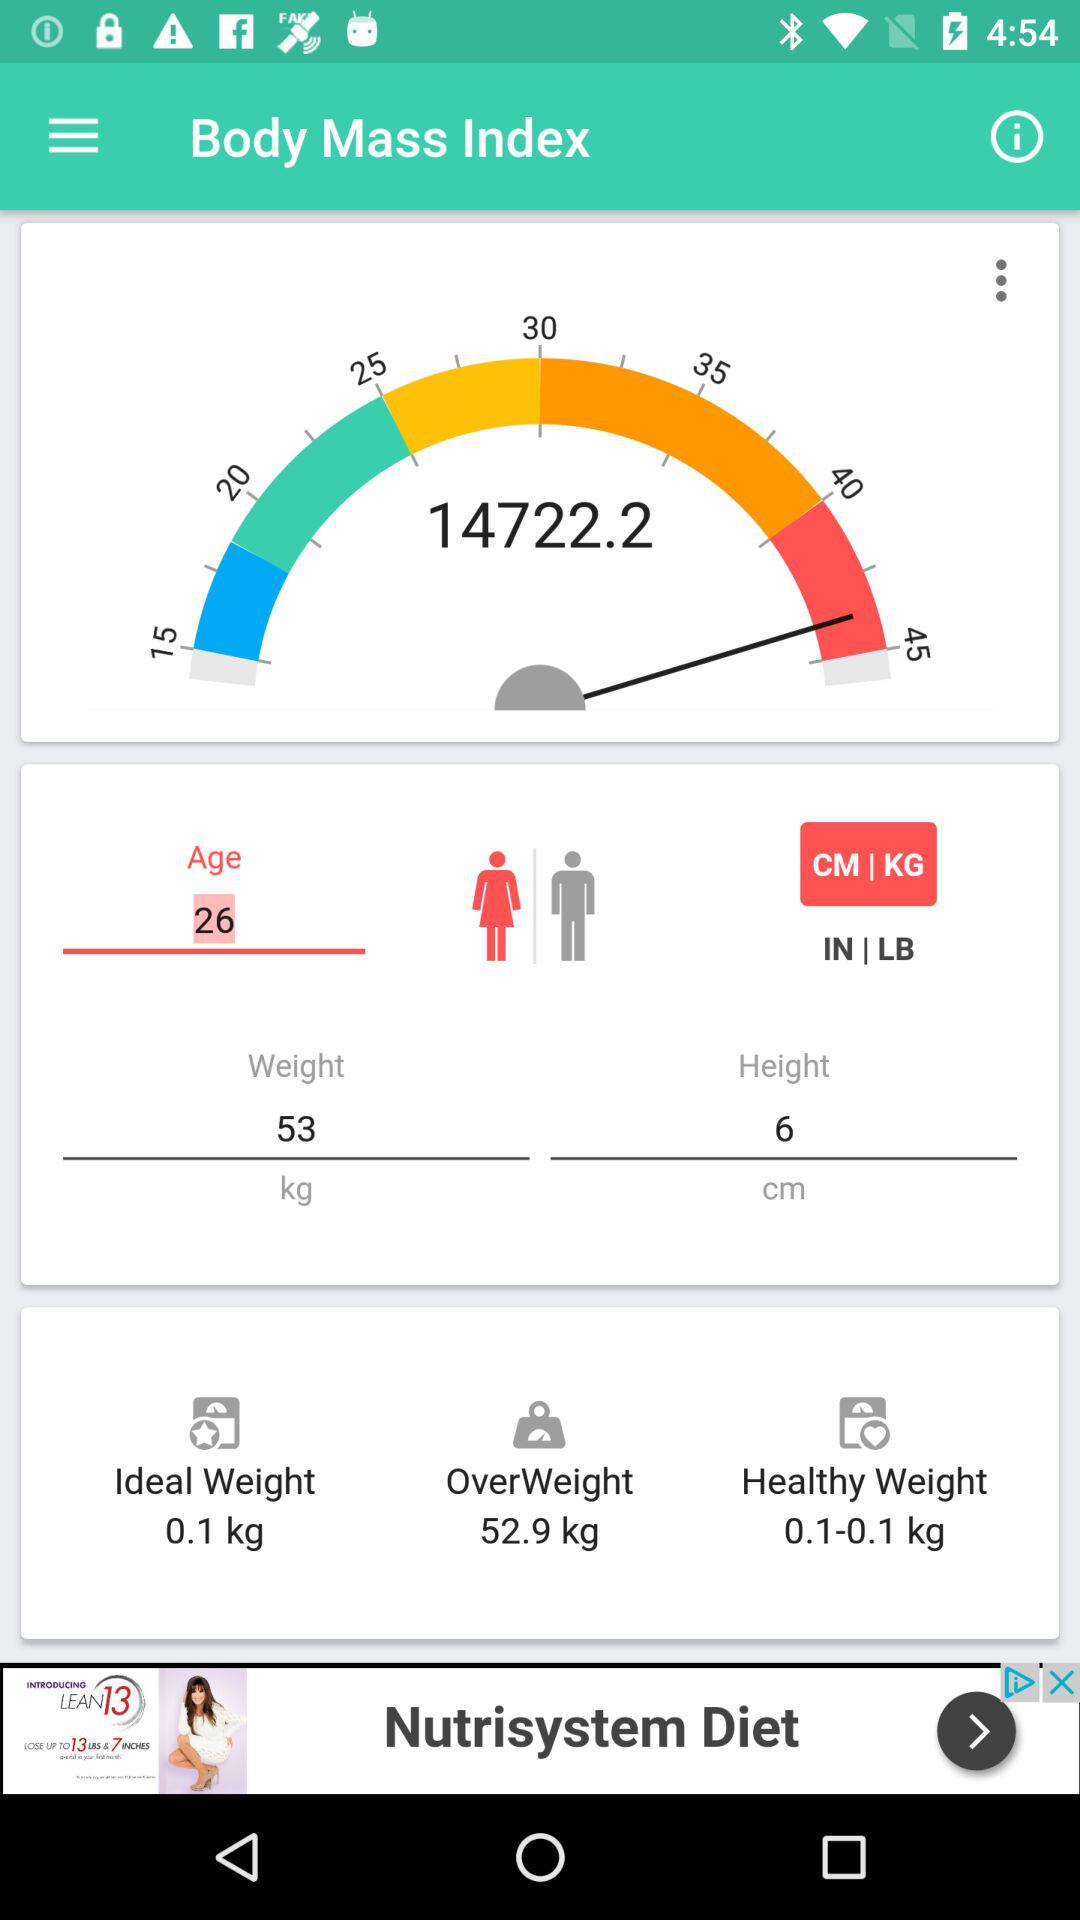What is the given age? The given age is 26. 